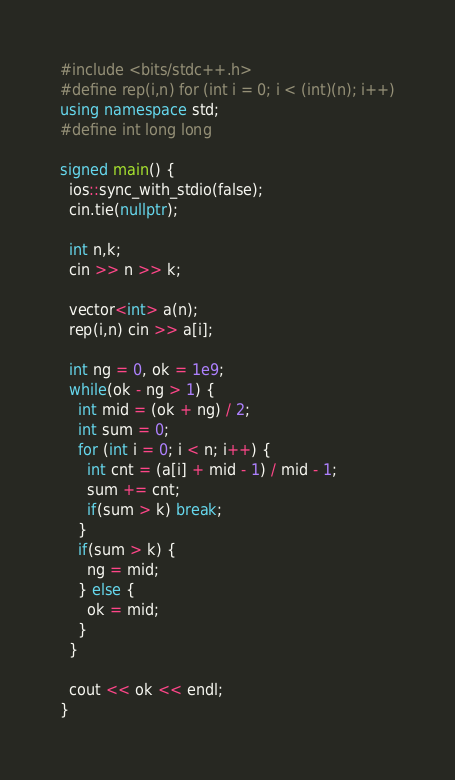Convert code to text. <code><loc_0><loc_0><loc_500><loc_500><_C++_>#include <bits/stdc++.h>
#define rep(i,n) for (int i = 0; i < (int)(n); i++)
using namespace std;
#define int long long

signed main() {
  ios::sync_with_stdio(false);
  cin.tie(nullptr);

  int n,k;
  cin >> n >> k;

  vector<int> a(n);
  rep(i,n) cin >> a[i];

  int ng = 0, ok = 1e9;
  while(ok - ng > 1) {
    int mid = (ok + ng) / 2;
    int sum = 0;
    for (int i = 0; i < n; i++) {
      int cnt = (a[i] + mid - 1) / mid - 1;
      sum += cnt;
      if(sum > k) break;
    }
    if(sum > k) {
      ng = mid;
    } else {
      ok = mid;
    }
  }

  cout << ok << endl;
}</code> 